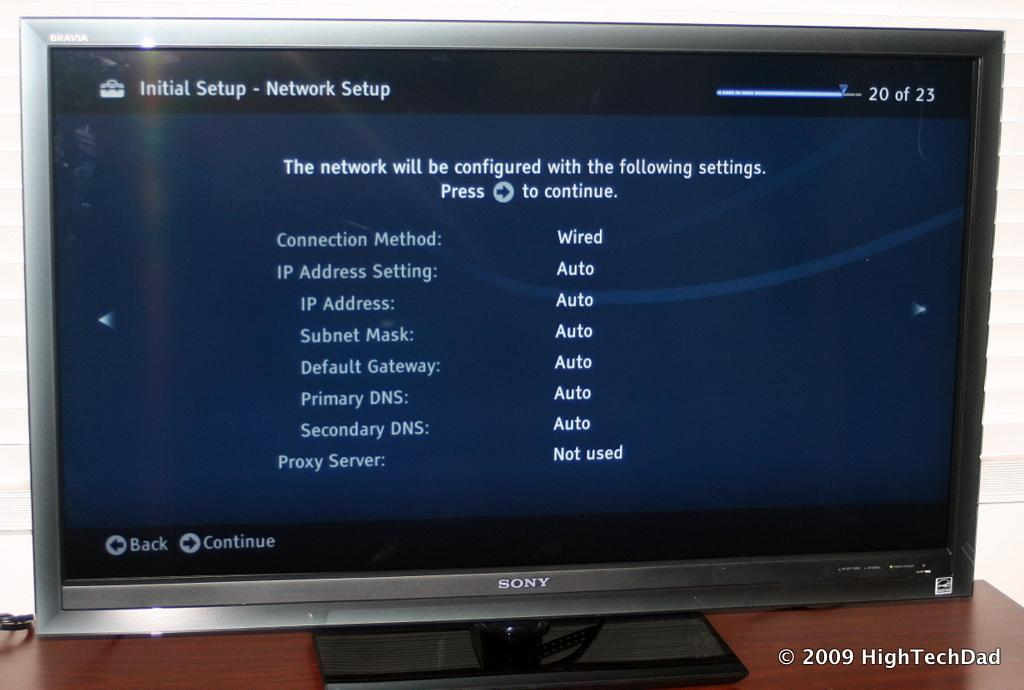<image>
Present a compact description of the photo's key features. A computer screen on the Initial Setup - Network Setup information screen. 